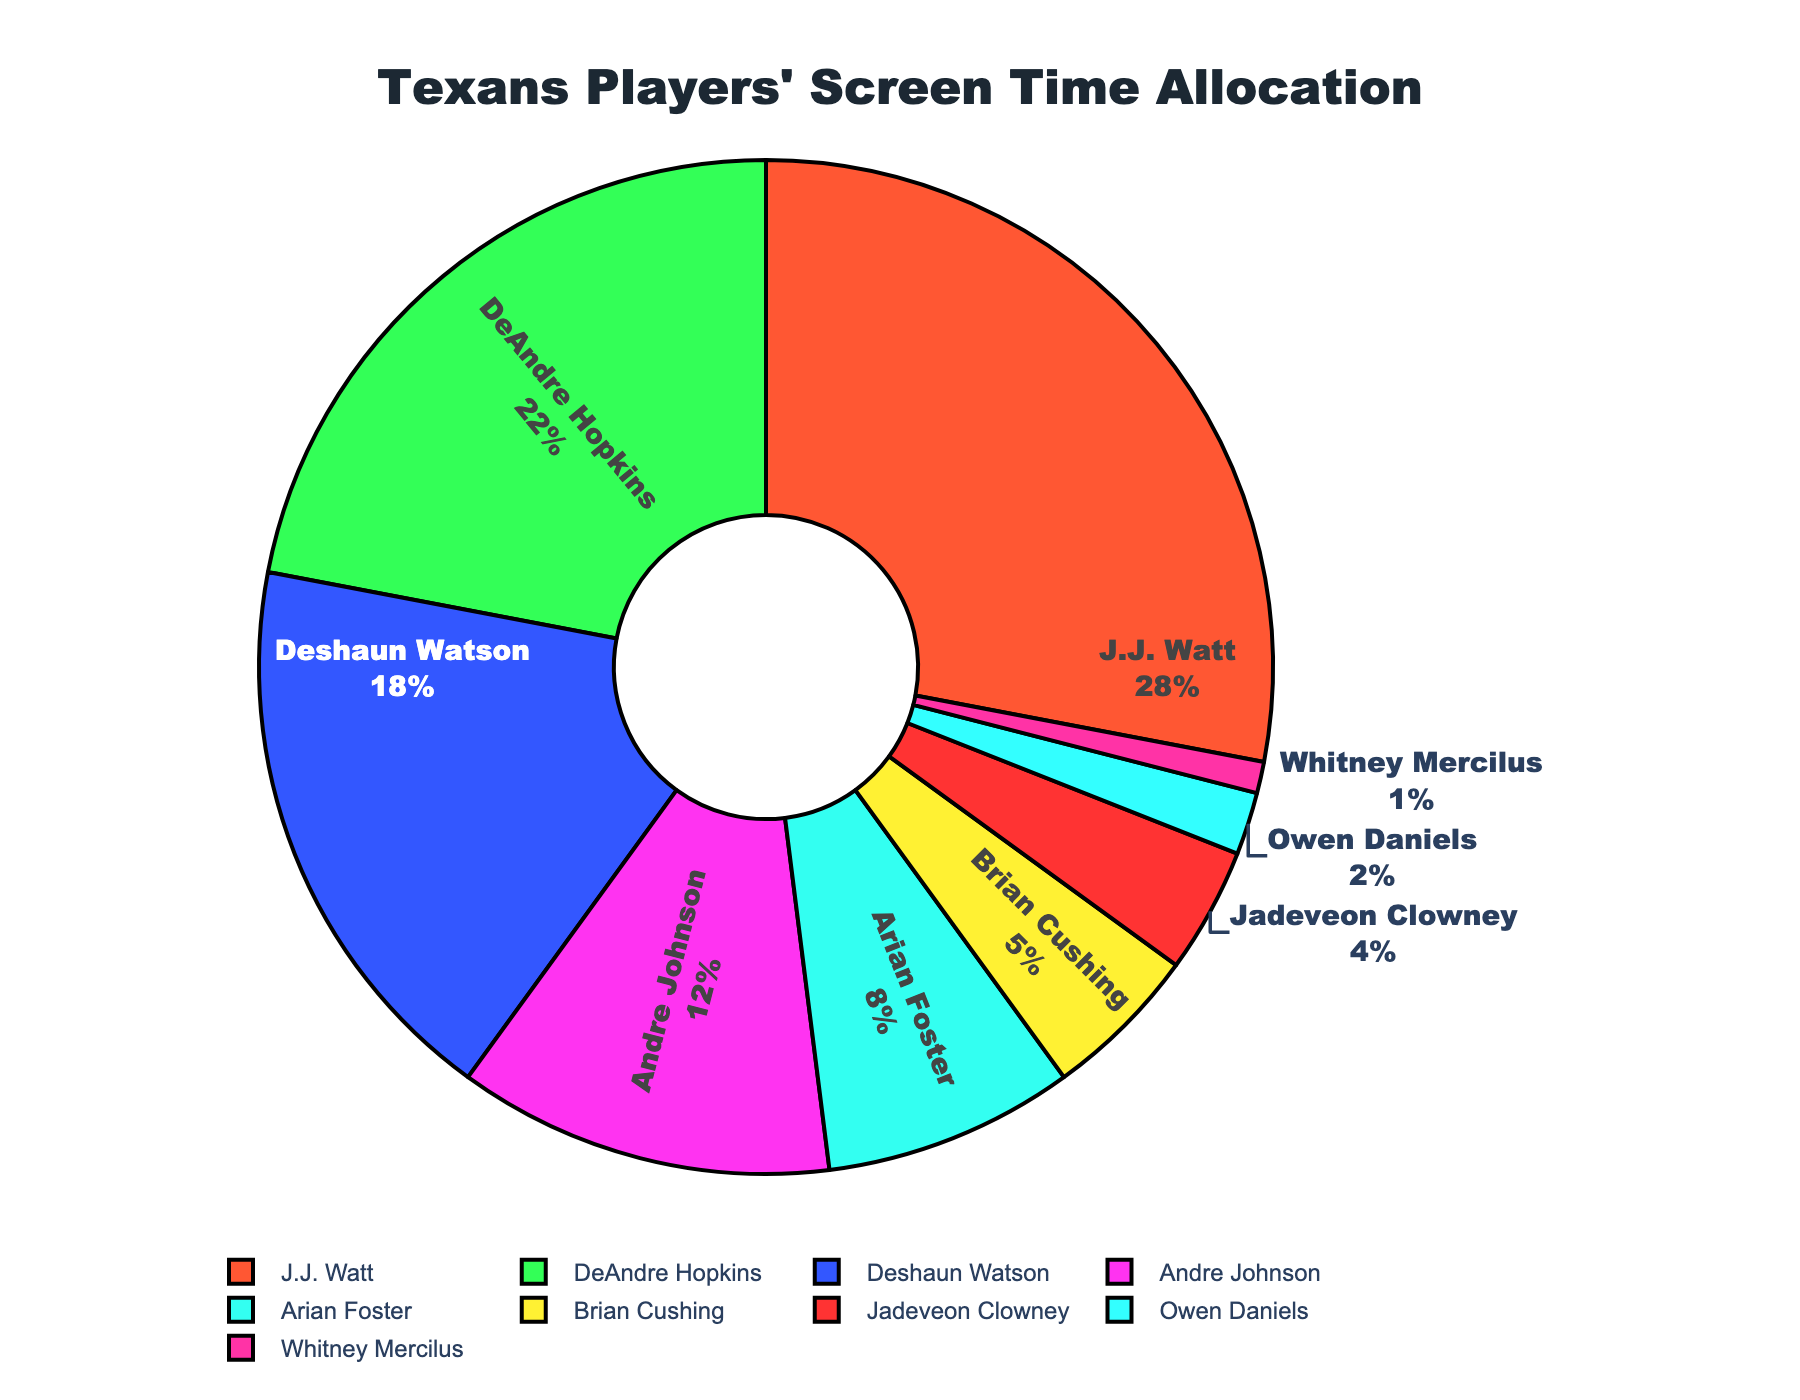What's the combined screen time percentage of DeAndre Hopkins and Deshaun Watson? To find the combined screen time percentage, add DeAndre Hopkins' percentage (22%) to Deshaun Watson's percentage (18%). 22 + 18 = 40
Answer: 40 Which player has the highest screen time percentage? By examining the pie chart, J.J. Watt has the largest segment, indicating the highest screen time percentage of 28%.
Answer: J.J. Watt Who has a higher screen time percentage, Andre Johnson or Arian Foster? Andre Johnson's screen time percentage is 12%, which is higher than Arian Foster's 8%.
Answer: Andre Johnson Out of Brian Cushing, Jadeveon Clowney, and Owen Daniels, who has the smallest screen time percentage and what is it? By comparing the segments for Brian Cushing (5%), Jadeveon Clowney (4%), and Owen Daniels (2%), Owen Daniels has the smallest screen time percentage.
Answer: Owen Daniels, 2% Which players have a combined screen time percentage greater than 30%? By adding player percentages until surpassing 30%: J.J. Watt (28%) + DeAndre Hopkins (22%) > 30%. So, J.J. Watt and DeAndre Hopkins together exceed 30%.
Answer: J.J. Watt and DeAndre Hopkins If the screen time percentages were adjusted such that Andre Johnson's percentage is doubled, what would his new percentage and the total adjusted percentage be? Doubling Andre Johnson's original percentage: 12% * 2 = 24%. The total adjusted percentage becomes 100% - 12% + 24% = 112% - 12% = 100%. The total percentage remains 100% with double Andre Johnson percentage changed to 24%.
Answer: 24%, 100% Which player has a screen time percentage closest to the average screen time percentage of all players? Sum all percentages and divide by the number of players: (28 + 22 + 18 + 12 + 8 + 5 + 4 + 2 + 1) / 9 = 100 / 9 ≈ 11.1%. Andre Johnson has a screen time of 12%, closest to this average.
Answer: Andre Johnson How does Arian Foster's screen time percentage compare to Jadeveon Clowney's? Arian Foster's screen time percentage (8%) is double that of Jadeveon Clowney's (4%).
Answer: Double Is the combined screen time percentage of J.J. Watt, DeAndre Hopkins, and Deshaun Watson greater than 60%? Adding the percentages of J.J. Watt (28%), DeAndre Hopkins (22%), and Deshaun Watson (18%) results in 68%, which is greater than 60%.
Answer: Yes Which player has a screen time percentage that is a prime number? Examining all percentages: 28, 22, 18, 12, 8, 5, 4, 2, and 1. The prime numbers in the list are 5 and 2. Therefore, Brian Cushing (5%) and Owen Daniels (2%) have prime number screen times.
Answer: Brian Cushing and Owen Daniels 